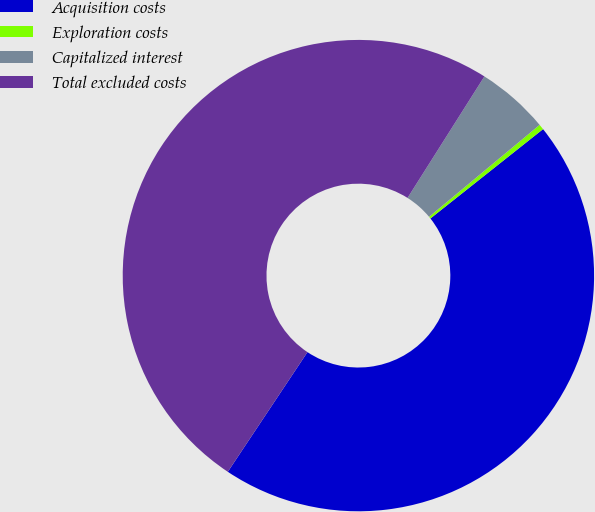<chart> <loc_0><loc_0><loc_500><loc_500><pie_chart><fcel>Acquisition costs<fcel>Exploration costs<fcel>Capitalized interest<fcel>Total excluded costs<nl><fcel>45.02%<fcel>0.37%<fcel>4.98%<fcel>49.63%<nl></chart> 